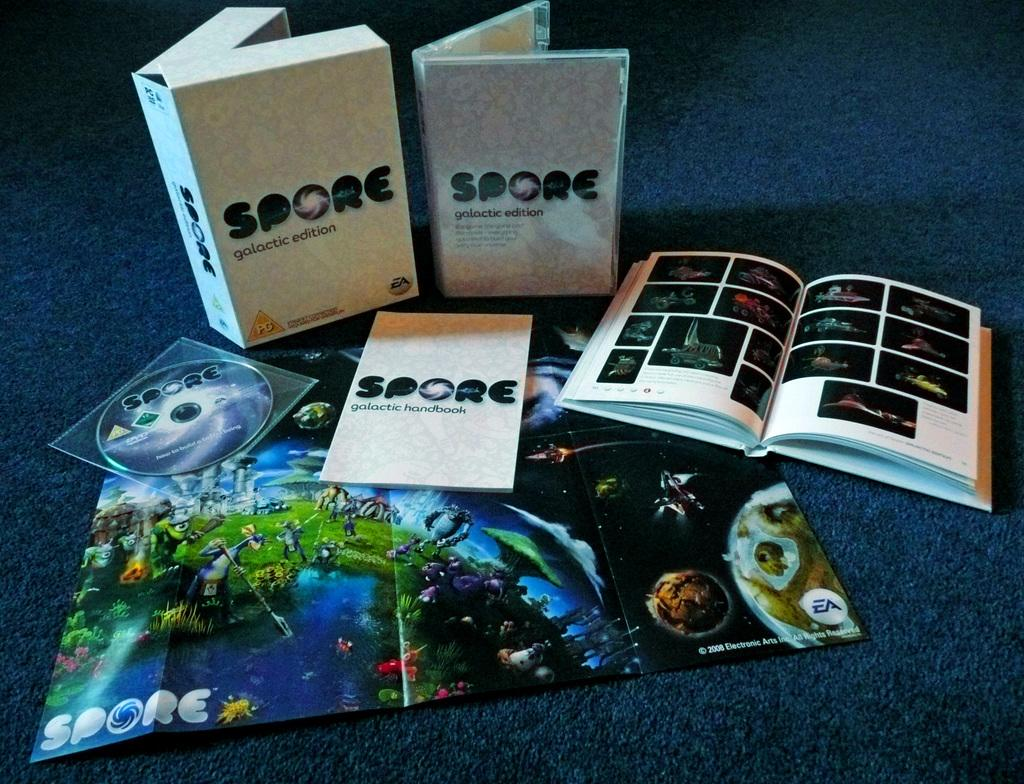<image>
Write a terse but informative summary of the picture. Several SPORE books and learning materials are open on a blue rug. 